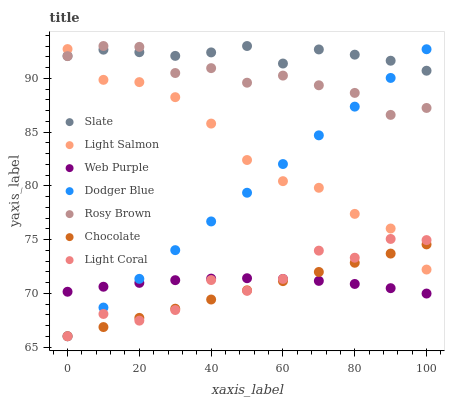Does Chocolate have the minimum area under the curve?
Answer yes or no. Yes. Does Slate have the maximum area under the curve?
Answer yes or no. Yes. Does Rosy Brown have the minimum area under the curve?
Answer yes or no. No. Does Rosy Brown have the maximum area under the curve?
Answer yes or no. No. Is Chocolate the smoothest?
Answer yes or no. Yes. Is Light Coral the roughest?
Answer yes or no. Yes. Is Slate the smoothest?
Answer yes or no. No. Is Slate the roughest?
Answer yes or no. No. Does Chocolate have the lowest value?
Answer yes or no. Yes. Does Rosy Brown have the lowest value?
Answer yes or no. No. Does Rosy Brown have the highest value?
Answer yes or no. Yes. Does Chocolate have the highest value?
Answer yes or no. No. Is Web Purple less than Slate?
Answer yes or no. Yes. Is Rosy Brown greater than Light Coral?
Answer yes or no. Yes. Does Rosy Brown intersect Dodger Blue?
Answer yes or no. Yes. Is Rosy Brown less than Dodger Blue?
Answer yes or no. No. Is Rosy Brown greater than Dodger Blue?
Answer yes or no. No. Does Web Purple intersect Slate?
Answer yes or no. No. 